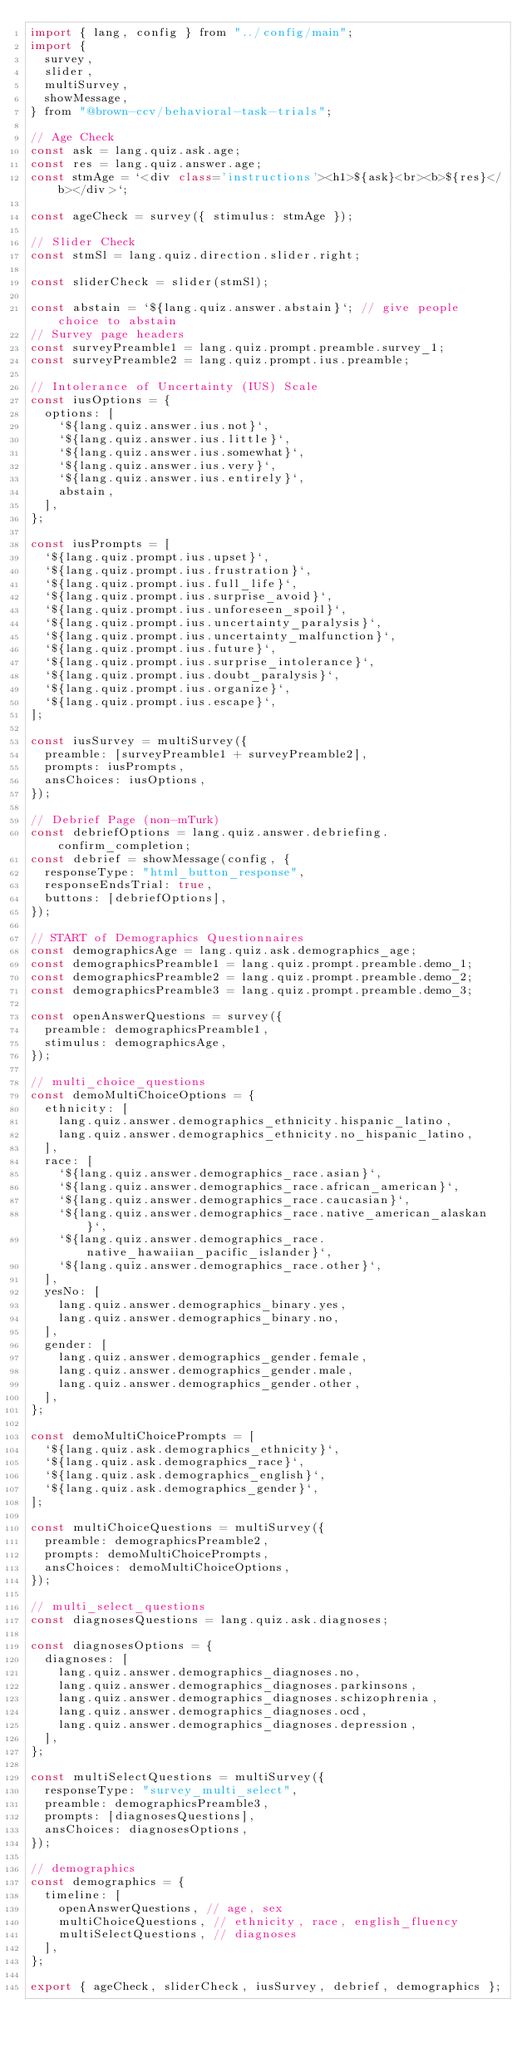<code> <loc_0><loc_0><loc_500><loc_500><_JavaScript_>import { lang, config } from "../config/main";
import {
  survey,
  slider,
  multiSurvey,
  showMessage,
} from "@brown-ccv/behavioral-task-trials";

// Age Check
const ask = lang.quiz.ask.age;
const res = lang.quiz.answer.age;
const stmAge = `<div class='instructions'><h1>${ask}<br><b>${res}</b></div>`;

const ageCheck = survey({ stimulus: stmAge });

// Slider Check
const stmSl = lang.quiz.direction.slider.right;

const sliderCheck = slider(stmSl);

const abstain = `${lang.quiz.answer.abstain}`; // give people choice to abstain
// Survey page headers
const surveyPreamble1 = lang.quiz.prompt.preamble.survey_1;
const surveyPreamble2 = lang.quiz.prompt.ius.preamble;

// Intolerance of Uncertainty (IUS) Scale
const iusOptions = {
  options: [
    `${lang.quiz.answer.ius.not}`,
    `${lang.quiz.answer.ius.little}`,
    `${lang.quiz.answer.ius.somewhat}`,
    `${lang.quiz.answer.ius.very}`,
    `${lang.quiz.answer.ius.entirely}`,
    abstain,
  ],
};

const iusPrompts = [
  `${lang.quiz.prompt.ius.upset}`,
  `${lang.quiz.prompt.ius.frustration}`,
  `${lang.quiz.prompt.ius.full_life}`,
  `${lang.quiz.prompt.ius.surprise_avoid}`,
  `${lang.quiz.prompt.ius.unforeseen_spoil}`,
  `${lang.quiz.prompt.ius.uncertainty_paralysis}`,
  `${lang.quiz.prompt.ius.uncertainty_malfunction}`,
  `${lang.quiz.prompt.ius.future}`,
  `${lang.quiz.prompt.ius.surprise_intolerance}`,
  `${lang.quiz.prompt.ius.doubt_paralysis}`,
  `${lang.quiz.prompt.ius.organize}`,
  `${lang.quiz.prompt.ius.escape}`,
];

const iusSurvey = multiSurvey({
  preamble: [surveyPreamble1 + surveyPreamble2],
  prompts: iusPrompts,
  ansChoices: iusOptions,
});

// Debrief Page (non-mTurk)
const debriefOptions = lang.quiz.answer.debriefing.confirm_completion;
const debrief = showMessage(config, {
  responseType: "html_button_response",
  responseEndsTrial: true,
  buttons: [debriefOptions],
});

// START of Demographics Questionnaires
const demographicsAge = lang.quiz.ask.demographics_age;
const demographicsPreamble1 = lang.quiz.prompt.preamble.demo_1;
const demographicsPreamble2 = lang.quiz.prompt.preamble.demo_2;
const demographicsPreamble3 = lang.quiz.prompt.preamble.demo_3;

const openAnswerQuestions = survey({
  preamble: demographicsPreamble1,
  stimulus: demographicsAge,
});

// multi_choice_questions
const demoMultiChoiceOptions = {
  ethnicity: [
    lang.quiz.answer.demographics_ethnicity.hispanic_latino,
    lang.quiz.answer.demographics_ethnicity.no_hispanic_latino,
  ],
  race: [
    `${lang.quiz.answer.demographics_race.asian}`,
    `${lang.quiz.answer.demographics_race.african_american}`,
    `${lang.quiz.answer.demographics_race.caucasian}`,
    `${lang.quiz.answer.demographics_race.native_american_alaskan}`,
    `${lang.quiz.answer.demographics_race.native_hawaiian_pacific_islander}`,
    `${lang.quiz.answer.demographics_race.other}`,
  ],
  yesNo: [
    lang.quiz.answer.demographics_binary.yes,
    lang.quiz.answer.demographics_binary.no,
  ],
  gender: [
    lang.quiz.answer.demographics_gender.female,
    lang.quiz.answer.demographics_gender.male,
    lang.quiz.answer.demographics_gender.other,
  ],
};

const demoMultiChoicePrompts = [
  `${lang.quiz.ask.demographics_ethnicity}`,
  `${lang.quiz.ask.demographics_race}`,
  `${lang.quiz.ask.demographics_english}`,
  `${lang.quiz.ask.demographics_gender}`,
];

const multiChoiceQuestions = multiSurvey({
  preamble: demographicsPreamble2,
  prompts: demoMultiChoicePrompts,
  ansChoices: demoMultiChoiceOptions,
});

// multi_select_questions
const diagnosesQuestions = lang.quiz.ask.diagnoses;

const diagnosesOptions = {
  diagnoses: [
    lang.quiz.answer.demographics_diagnoses.no,
    lang.quiz.answer.demographics_diagnoses.parkinsons,
    lang.quiz.answer.demographics_diagnoses.schizophrenia,
    lang.quiz.answer.demographics_diagnoses.ocd,
    lang.quiz.answer.demographics_diagnoses.depression,
  ],
};

const multiSelectQuestions = multiSurvey({
  responseType: "survey_multi_select",
  preamble: demographicsPreamble3,
  prompts: [diagnosesQuestions],
  ansChoices: diagnosesOptions,
});

// demographics
const demographics = {
  timeline: [
    openAnswerQuestions, // age, sex
    multiChoiceQuestions, // ethnicity, race, english_fluency
    multiSelectQuestions, // diagnoses
  ],
};

export { ageCheck, sliderCheck, iusSurvey, debrief, demographics };
</code> 